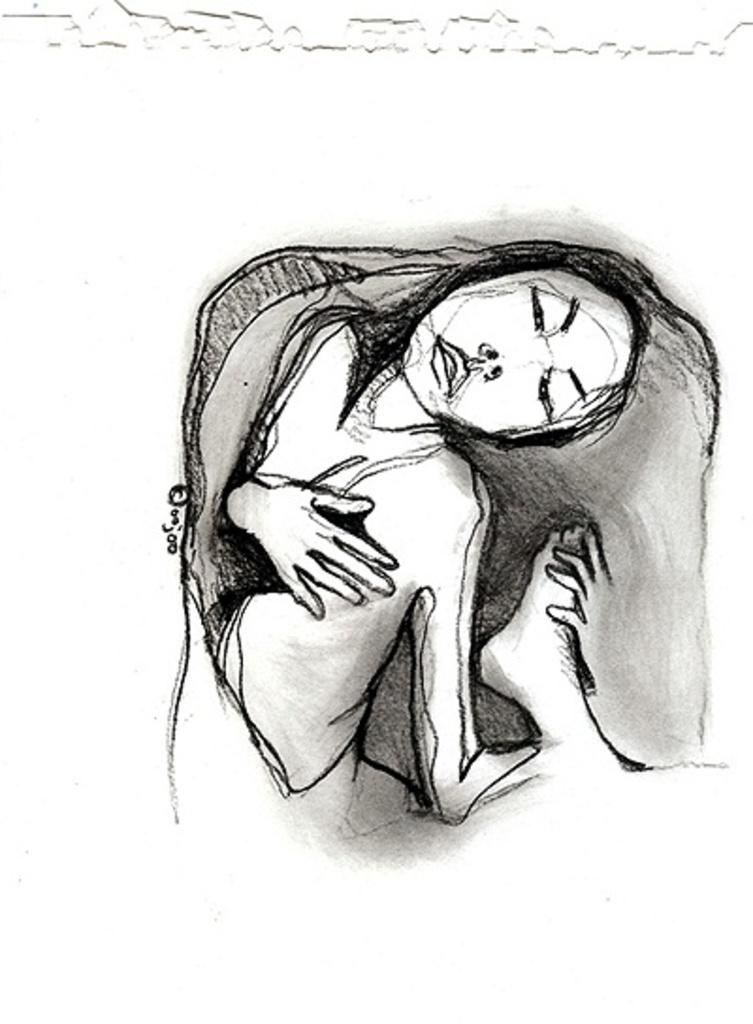What is the main subject of the image? The main subject of the image is a drawing of a woman. What color is the background of the image? The background of the image is white. What decision does the woman's father make in the image? There is no mention of a father or any decision-making in the image, as it only features a drawing of a woman with a white background. 